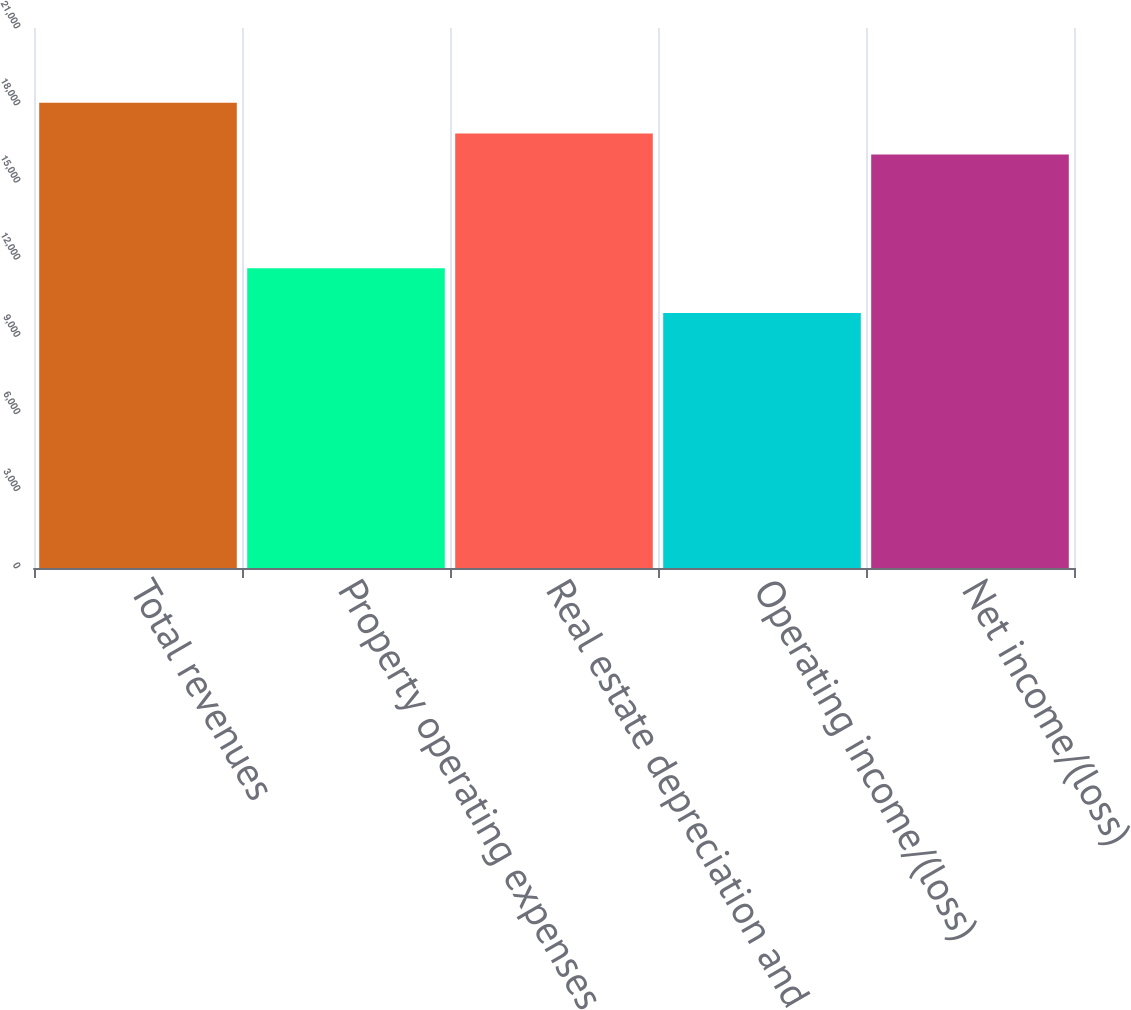<chart> <loc_0><loc_0><loc_500><loc_500><bar_chart><fcel>Total revenues<fcel>Property operating expenses<fcel>Real estate depreciation and<fcel>Operating income/(loss)<fcel>Net income/(loss)<nl><fcel>18090<fcel>11655<fcel>16899.2<fcel>9918<fcel>16082<nl></chart> 